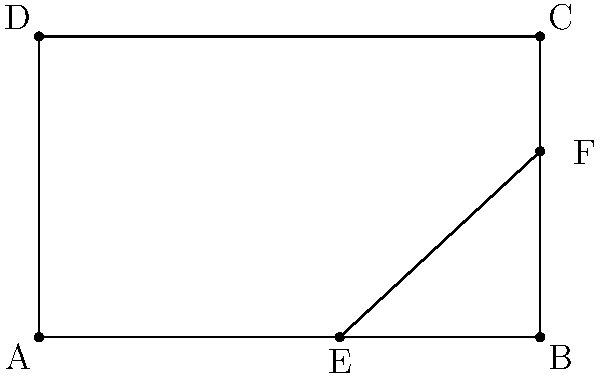In nature photography, the golden ratio is often used to create visually appealing compositions. How does the ratio of the lengths of AE to EB in the rectangle ABCD relate to the golden ratio? (Assume AE:EB ≈ 1.618:1) To understand how the ratio of AE to EB relates to the golden ratio, let's follow these steps:

1. The golden ratio, denoted by φ (phi), is approximately 1.618034...

2. In the given rectangle ABCD, point E divides the base AB such that AE:EB ≈ 1.618:1

3. This division of AB follows the golden ratio principle, where:
   $\frac{AE}{EB} \approx \frac{AB}{AE} \approx \phi \approx 1.618$

4. The golden ratio creates a "golden rectangle," where the ratio of the longer side to the shorter side is equal to φ.

5. In this case, AEFC forms a golden rectangle, as:
   $\frac{AC}{AE} \approx \frac{AE}{EB} \approx \phi$

6. The golden ratio is found throughout nature, such as in the spiral patterns of shells, the arrangement of leaves on plants, and the proportions of many flowers.

7. In nature photography, composing images using the golden ratio can create a sense of balance and visual harmony that mimics patterns found in nature.

Therefore, the ratio of AE to EB in the rectangle ABCD directly represents the golden ratio, which is a fundamental principle in both nature and artistic composition.
Answer: AE:EB represents the golden ratio (φ ≈ 1.618:1) 